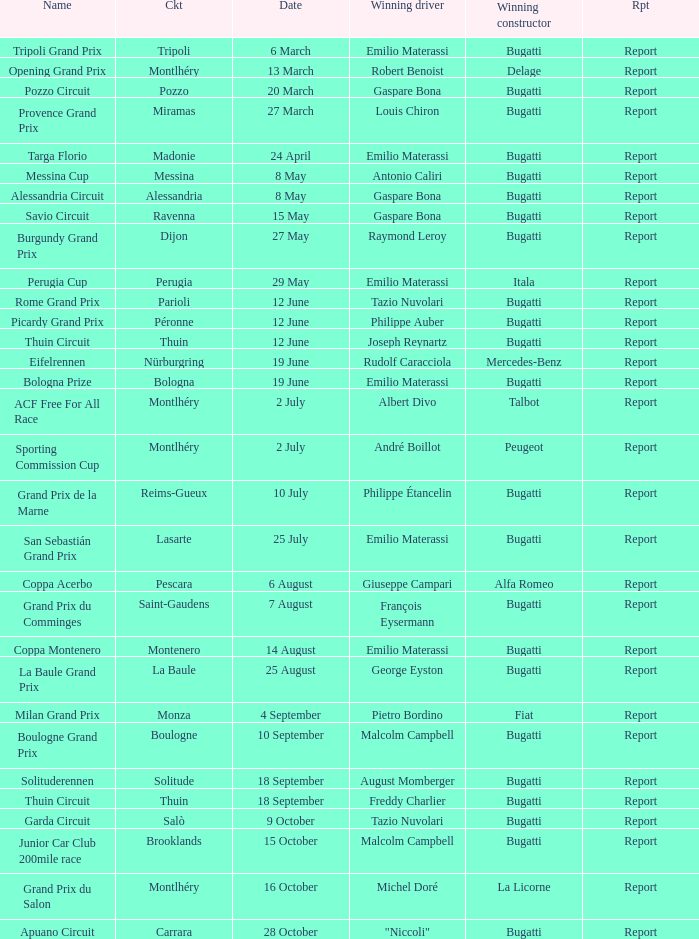Which circuit did françois eysermann win ? Saint-Gaudens. 